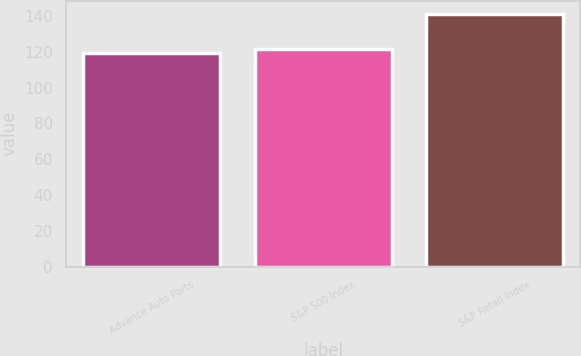Convert chart to OTSL. <chart><loc_0><loc_0><loc_500><loc_500><bar_chart><fcel>Advance Auto Parts<fcel>S&P 500 Index<fcel>S&P Retail Index<nl><fcel>119.28<fcel>121.48<fcel>141.28<nl></chart> 